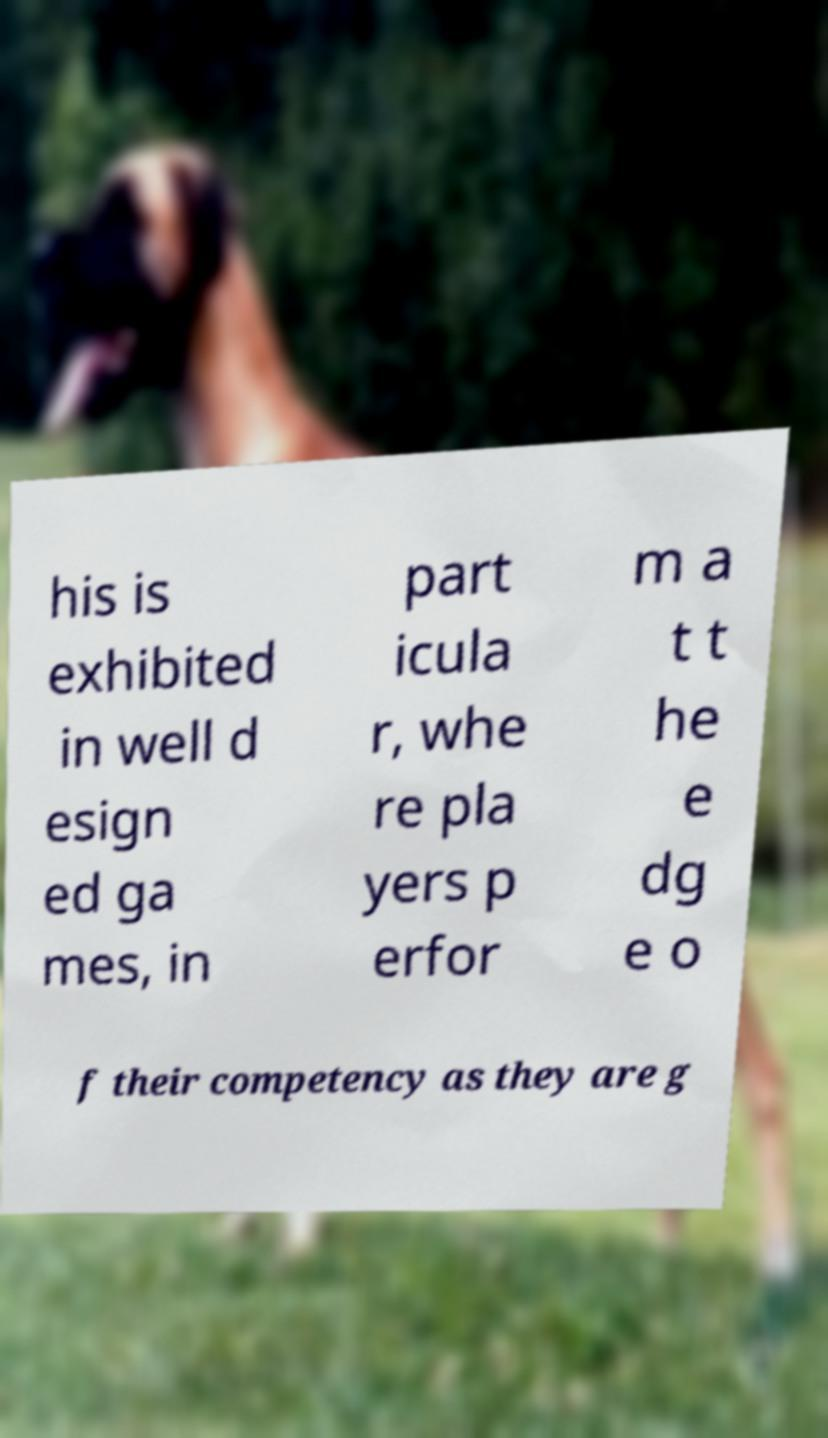For documentation purposes, I need the text within this image transcribed. Could you provide that? his is exhibited in well d esign ed ga mes, in part icula r, whe re pla yers p erfor m a t t he e dg e o f their competency as they are g 